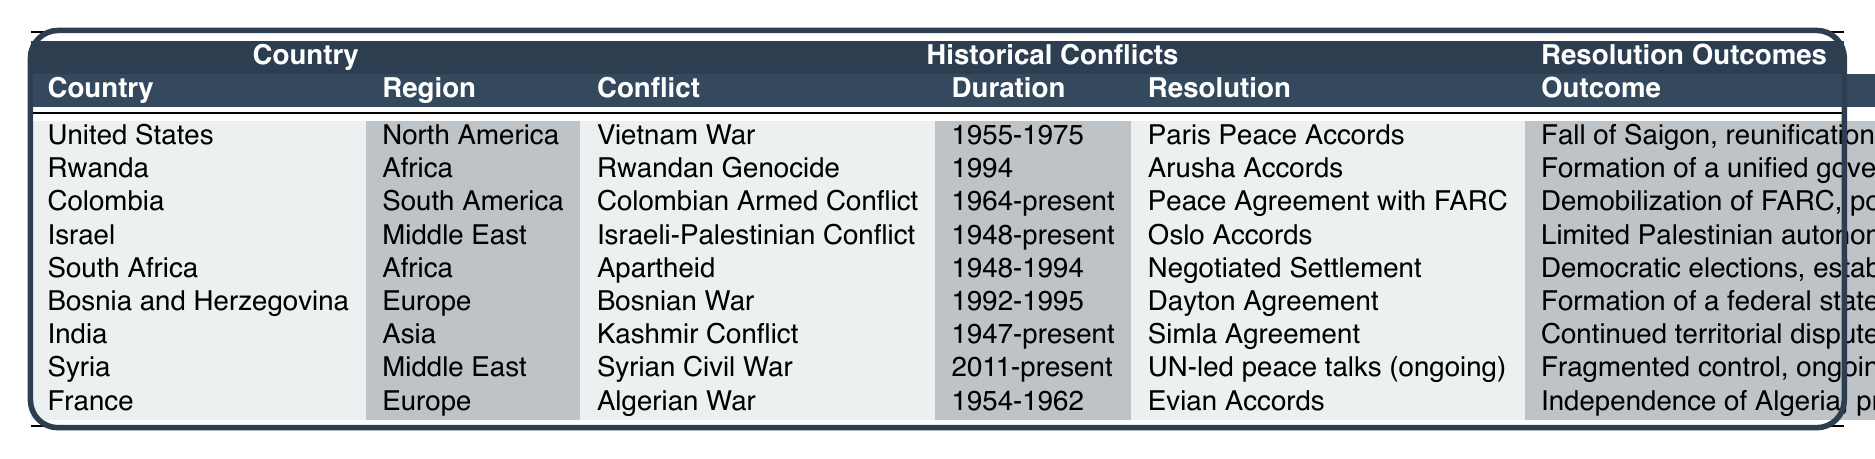What is the duration of the Colombian Armed Conflict? The table lists the duration of the Colombian Armed Conflict as "1964-present."
Answer: 1964-present Which country has the longest ongoing conflict according to the table? The Kashmir Conflict, which has been ongoing since 1947, is the longest ongoing conflict listed in the table.
Answer: India What resolution ended the Rwandan Genocide? The table states that the resolution that ended the Rwandan Genocide is the "Arusha Accords."
Answer: Arusha Accords Did the United States' involvement in the Vietnam War end with a formal resolution? Yes, the table indicates that the Vietnam War concluded with the "Paris Peace Accords."
Answer: Yes How many countries listed have conflicts lasting over 20 years? The conflicts in the table that have lasted over 20 years are: the Colombian Armed Conflict (1964-present) and the Israeli-Palestinian Conflict (1948-present), along with the Kashmir Conflict (1947-present), totaling three conflicts.
Answer: Three What outcome is associated with the peace agreement related to the Colombian Armed Conflict? The table states that the outcome was the "Demobilization of FARC, political integration."
Answer: Demobilization of FARC, political integration Are the Arusha Accords considered successful based on the outcome listed? Yes, the outcome includes the formation of a unified government and the establishment of Gacaca courts, indicating a level of success.
Answer: Yes Which two countries have resolutions that led to a significant change in government structure? The countries are South Africa, which had a negotiated settlement leading to a multi-racial government, and Rwanda, which formed a unified government after the Arusha Accords.
Answer: South Africa and Rwanda What is the resolution associated with the Israeli-Palestinian Conflict? According to the table, the resolution associated with the Israeli-Palestinian Conflict is the "Oslo Accords."
Answer: Oslo Accords How many conflicts listed have not resulted in a complete resolution according to their outcomes? The Syrian Civil War and the Israeli-Palestinian Conflict have ongoing tensions or humanitarian crises, which indicates incomplete resolutions; this makes two conflicts.
Answer: Two 